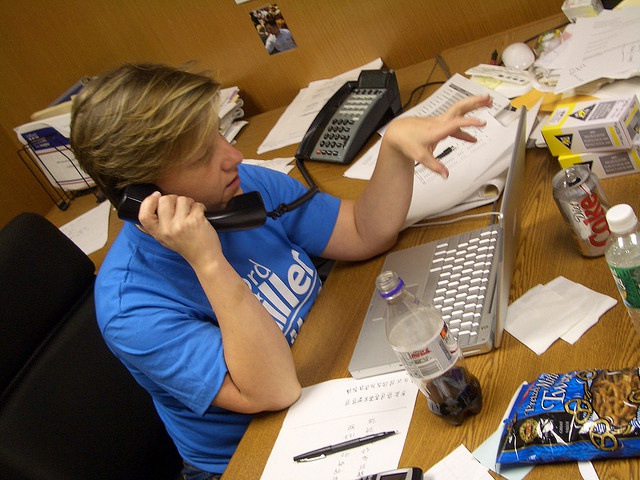Describe the objects in this image and their specific colors. I can see people in maroon, blue, gray, black, and tan tones, chair in maroon, black, blue, navy, and darkblue tones, laptop in maroon, darkgray, and gray tones, bottle in maroon, darkgray, black, and gray tones, and book in maroon, tan, black, and gray tones in this image. 